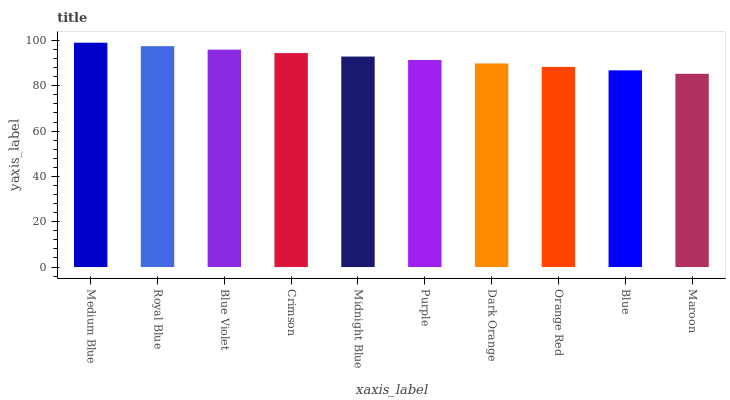Is Royal Blue the minimum?
Answer yes or no. No. Is Royal Blue the maximum?
Answer yes or no. No. Is Medium Blue greater than Royal Blue?
Answer yes or no. Yes. Is Royal Blue less than Medium Blue?
Answer yes or no. Yes. Is Royal Blue greater than Medium Blue?
Answer yes or no. No. Is Medium Blue less than Royal Blue?
Answer yes or no. No. Is Midnight Blue the high median?
Answer yes or no. Yes. Is Purple the low median?
Answer yes or no. Yes. Is Maroon the high median?
Answer yes or no. No. Is Medium Blue the low median?
Answer yes or no. No. 